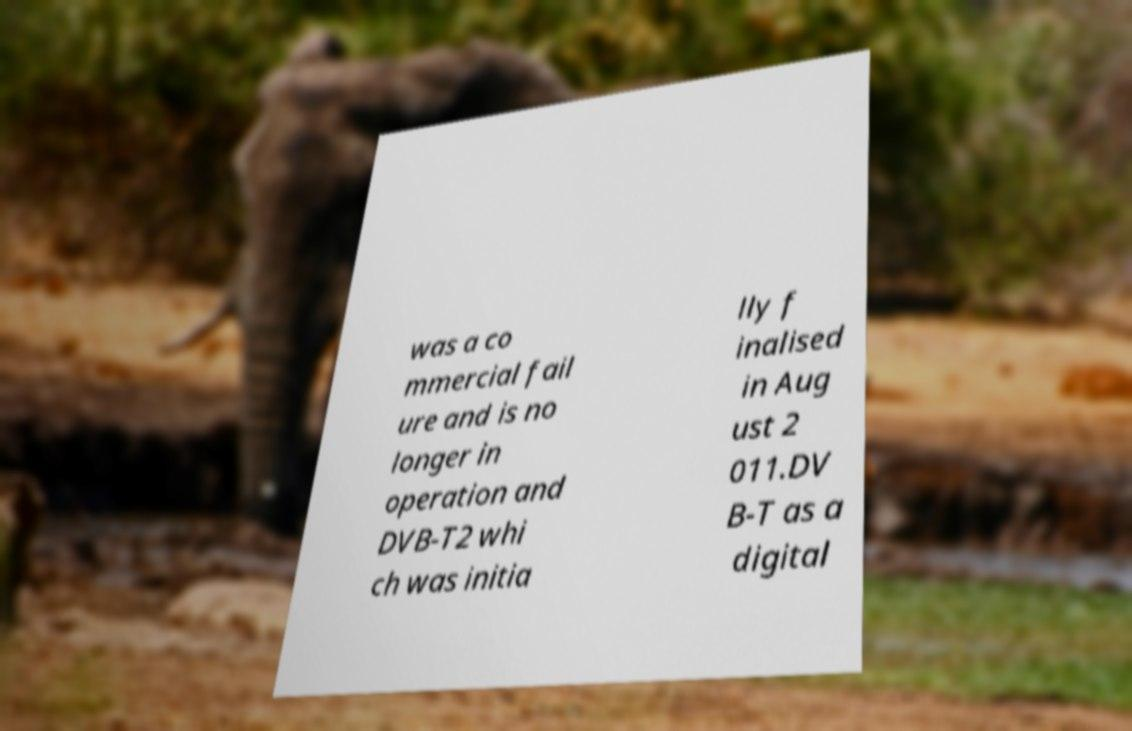Please identify and transcribe the text found in this image. was a co mmercial fail ure and is no longer in operation and DVB-T2 whi ch was initia lly f inalised in Aug ust 2 011.DV B-T as a digital 